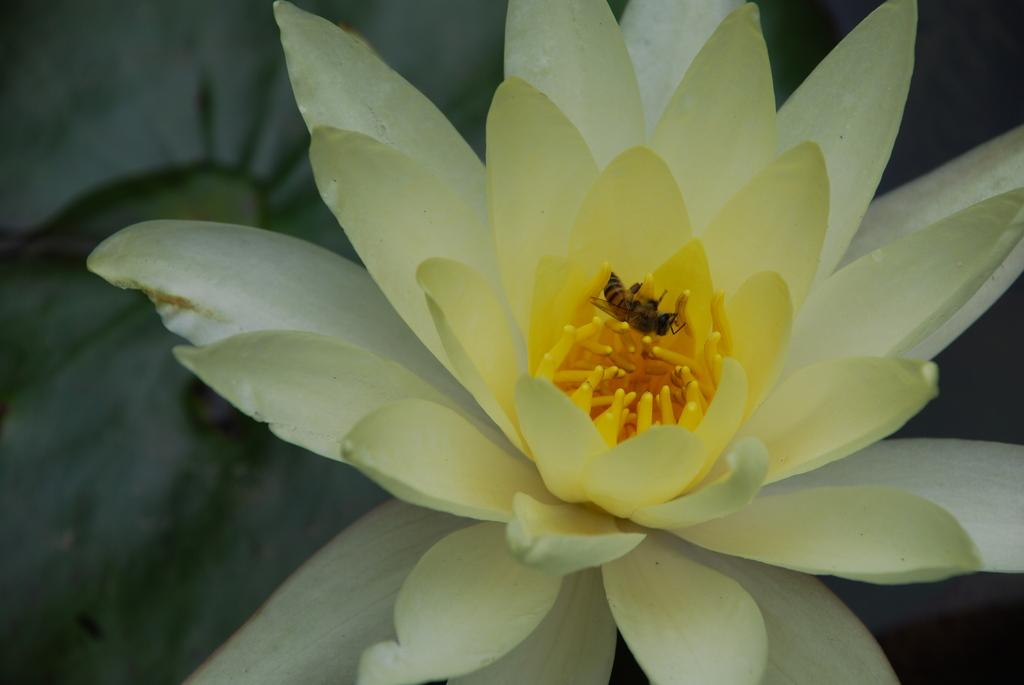What type of flower is present in the image? There is a white flower in the image. Is there anything else present on the flower in the image? Yes, there is an insect on the flower in the image. What type of war is being depicted in the image? There is no depiction of war in the image; it features a white flower with an insect on it. Can you see a kitty playing with the insect in the image? There is no kitty present in the image. 